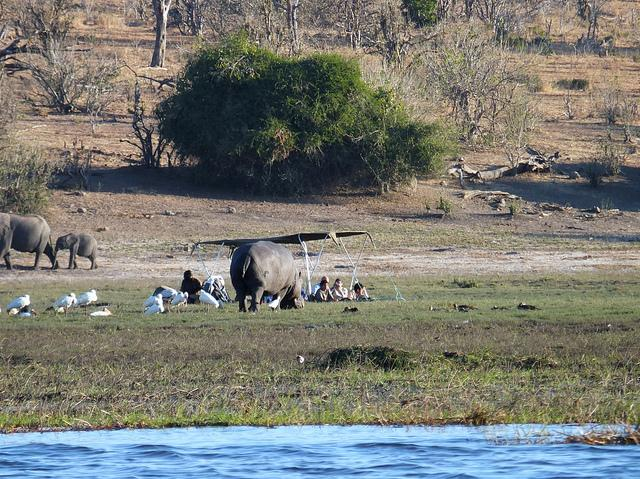Who are in the most danger? people 